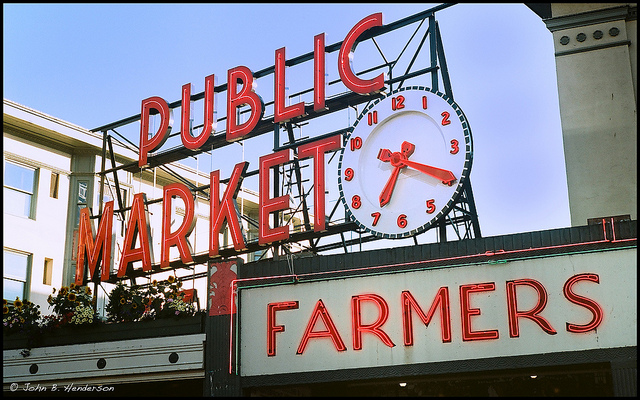Please identify all text content in this image. PUBLIC FARMERS 12 II 9 10 8 7 6 5 3 2 1 8 